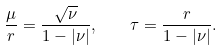Convert formula to latex. <formula><loc_0><loc_0><loc_500><loc_500>\frac { \mu } { r } = \frac { \sqrt { \nu } } { 1 - | \nu | } , \quad \tau = \frac { r } { 1 - | \nu | } .</formula> 